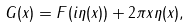Convert formula to latex. <formula><loc_0><loc_0><loc_500><loc_500>G ( x ) = F ( i \eta ( x ) ) + 2 \pi x \eta ( x ) ,</formula> 